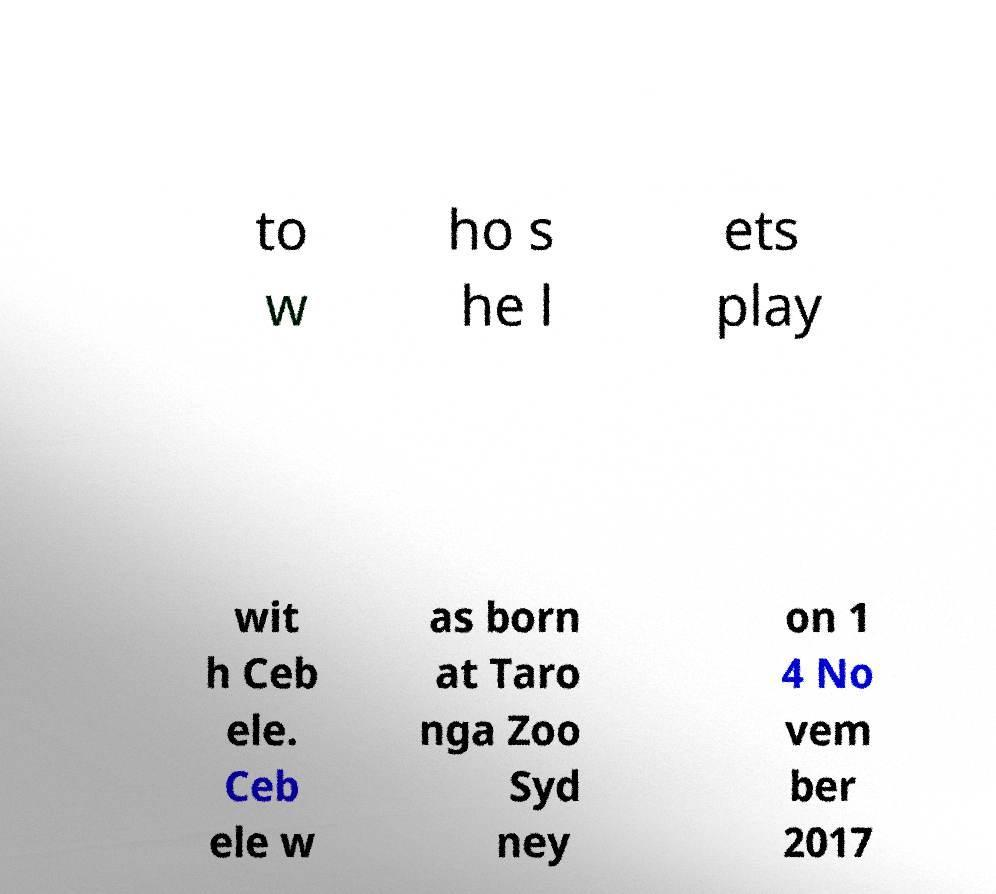I need the written content from this picture converted into text. Can you do that? to w ho s he l ets play wit h Ceb ele. Ceb ele w as born at Taro nga Zoo Syd ney on 1 4 No vem ber 2017 